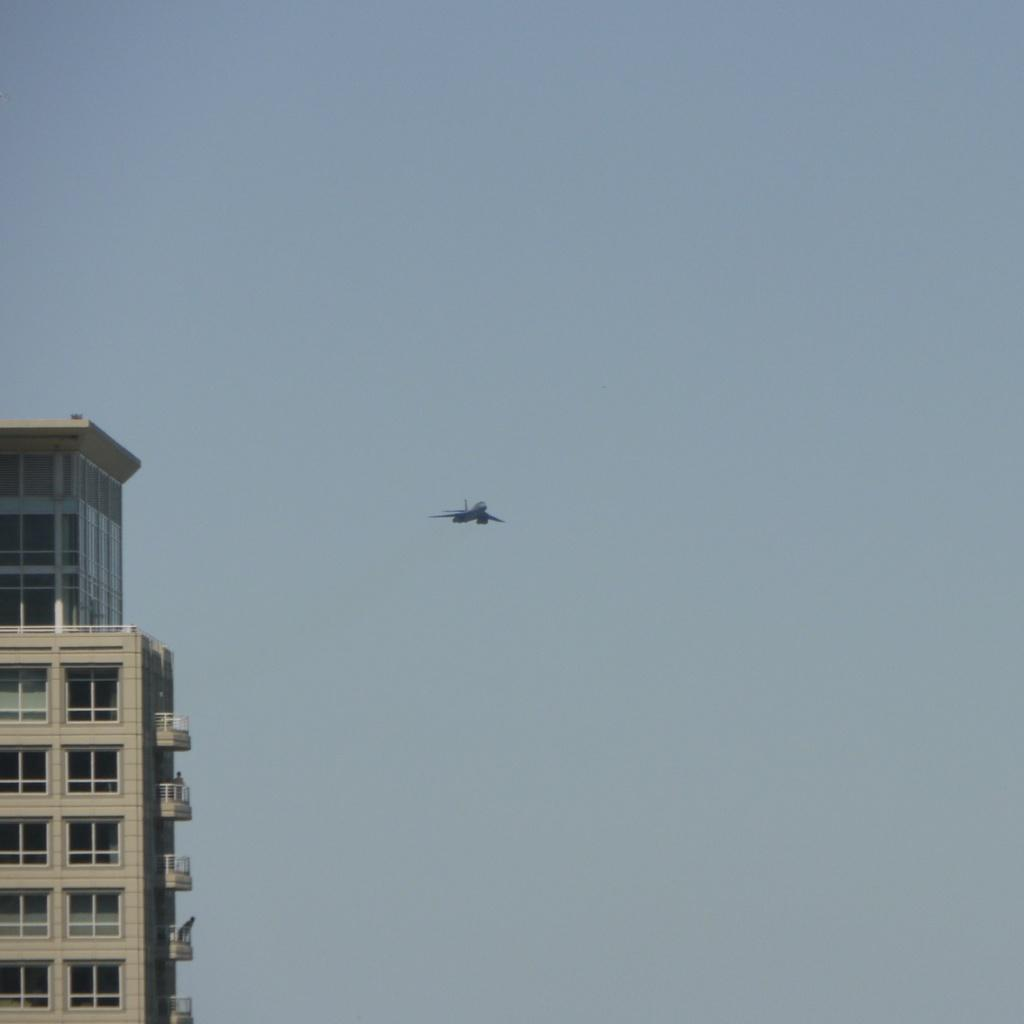What type of structure is located on the left side of the image? There is a tower building on the left side of the image. What is happening in the air in the image? There is an airplane flying in the air. What can be seen in the background of the image? The sky is visible in the background of the image. How many fowl are sitting on the tower building in the image? There are no fowl present on the tower building in the image. What does the airplane's mouth look like in the image? Airplanes do not have mouths, so this question cannot be answered. 